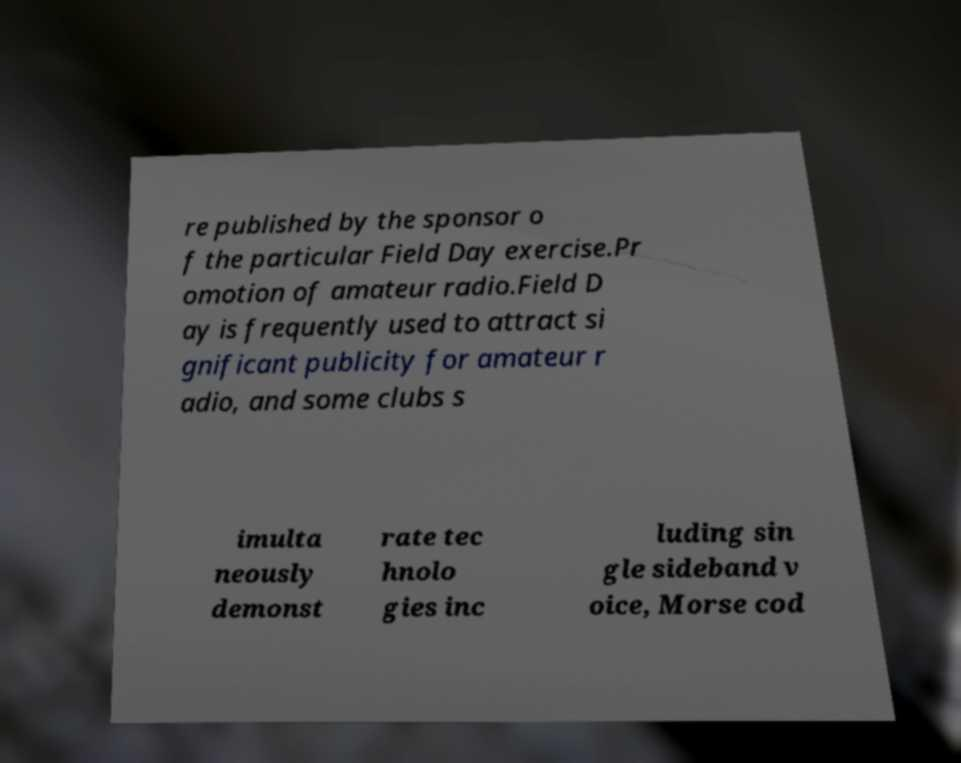There's text embedded in this image that I need extracted. Can you transcribe it verbatim? re published by the sponsor o f the particular Field Day exercise.Pr omotion of amateur radio.Field D ay is frequently used to attract si gnificant publicity for amateur r adio, and some clubs s imulta neously demonst rate tec hnolo gies inc luding sin gle sideband v oice, Morse cod 